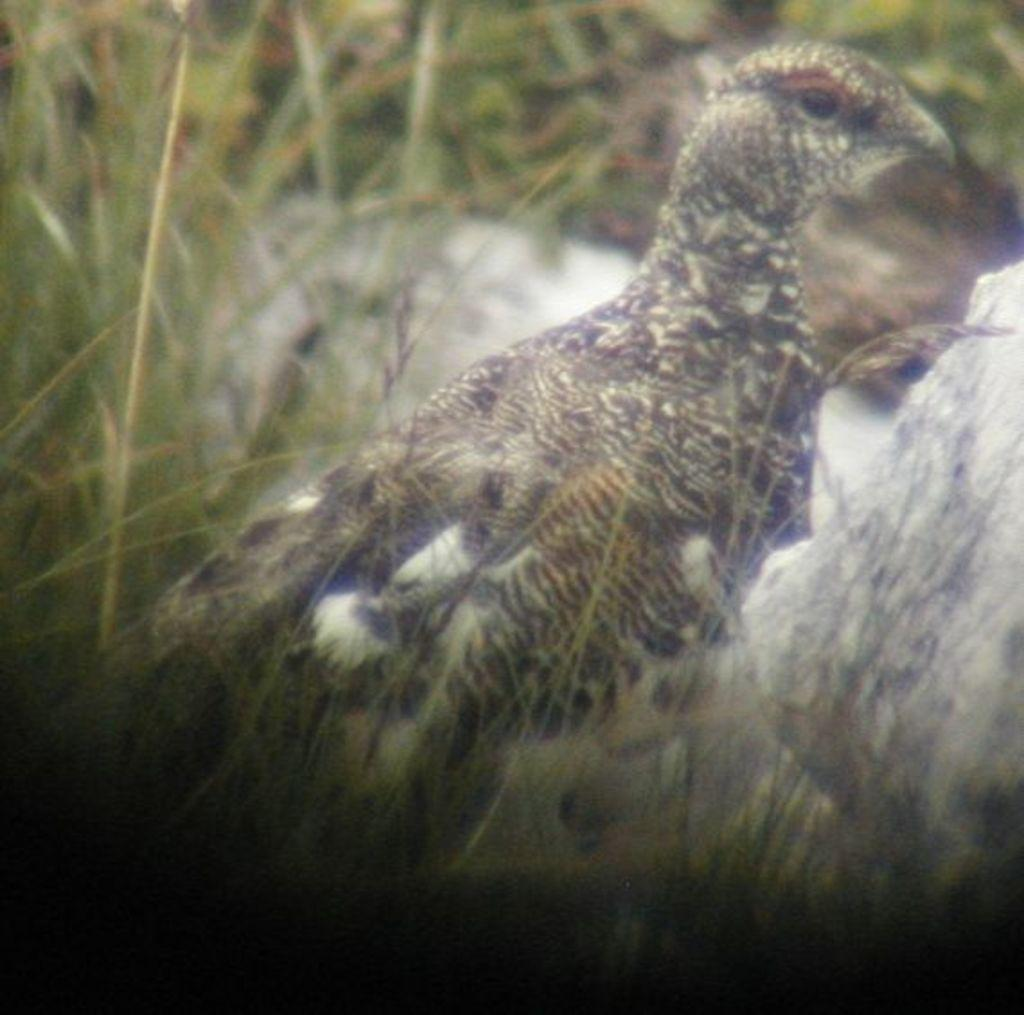What is the main subject of the image? There is a bird in the center of the image. What type of environment is visible in the background? There is grass visible in the background of the image. What type of quilt is being used to keep the bird warm in the image? There is no quilt present in the image, and the bird's warmth is not mentioned or depicted. 